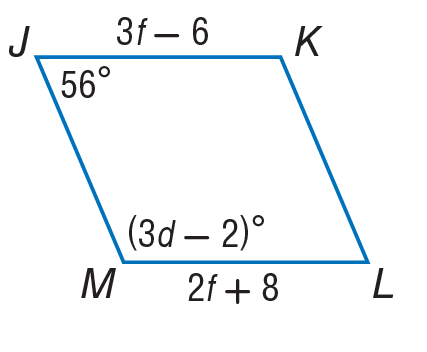Answer the mathemtical geometry problem and directly provide the correct option letter.
Question: Find the value of d in the parallelogram.
Choices: A: 42 B: 56 C: 84 D: 92 A 